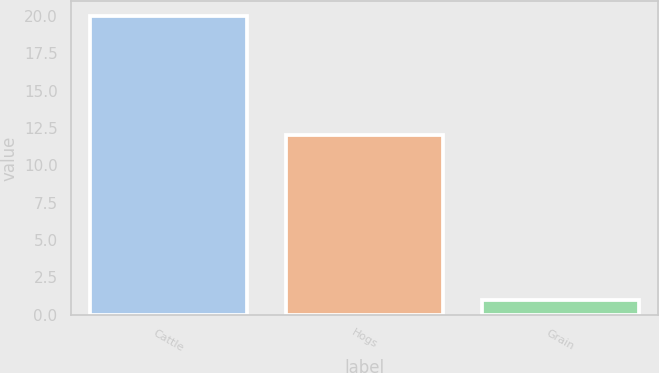<chart> <loc_0><loc_0><loc_500><loc_500><bar_chart><fcel>Cattle<fcel>Hogs<fcel>Grain<nl><fcel>20<fcel>12<fcel>1<nl></chart> 